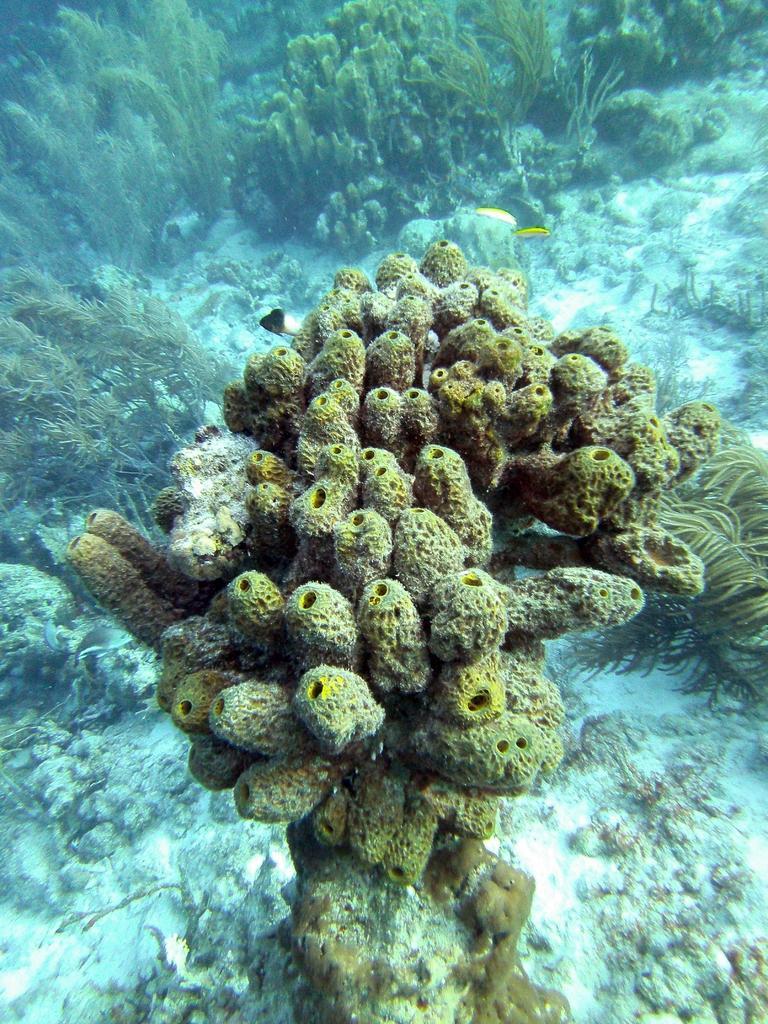Please provide a concise description of this image. In this image, we can see underwater environment. 